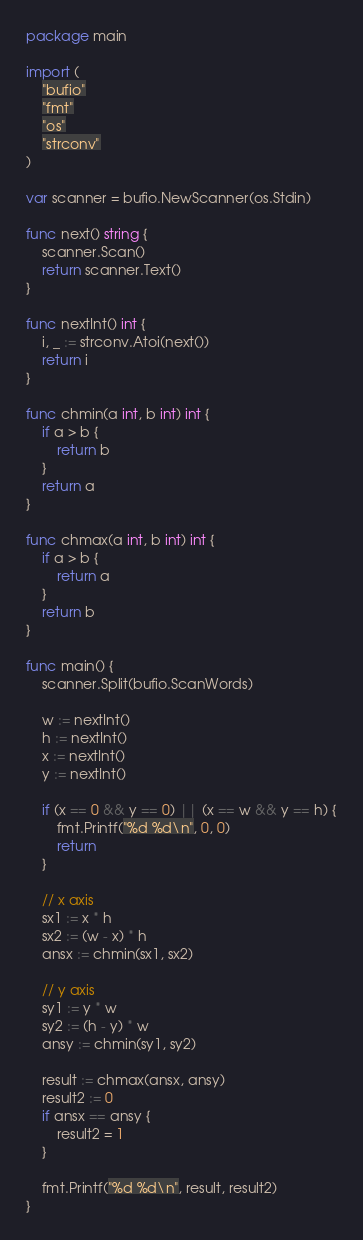Convert code to text. <code><loc_0><loc_0><loc_500><loc_500><_Go_>package main

import (
	"bufio"
	"fmt"
	"os"
	"strconv"
)

var scanner = bufio.NewScanner(os.Stdin)

func next() string {
	scanner.Scan()
	return scanner.Text()
}

func nextInt() int {
	i, _ := strconv.Atoi(next())
	return i
}

func chmin(a int, b int) int {
	if a > b {
		return b
	}
	return a
}

func chmax(a int, b int) int {
	if a > b {
		return a
	}
	return b
}

func main() {
	scanner.Split(bufio.ScanWords)

	w := nextInt()
	h := nextInt()
	x := nextInt()
	y := nextInt()

	if (x == 0 && y == 0) || (x == w && y == h) {
		fmt.Printf("%d %d\n", 0, 0)
		return
	}

	// x axis
	sx1 := x * h
	sx2 := (w - x) * h
	ansx := chmin(sx1, sx2)

	// y axis
	sy1 := y * w
	sy2 := (h - y) * w
	ansy := chmin(sy1, sy2)

	result := chmax(ansx, ansy)
	result2 := 0
	if ansx == ansy {
		result2 = 1
	}

	fmt.Printf("%d %d\n", result, result2)
}
</code> 